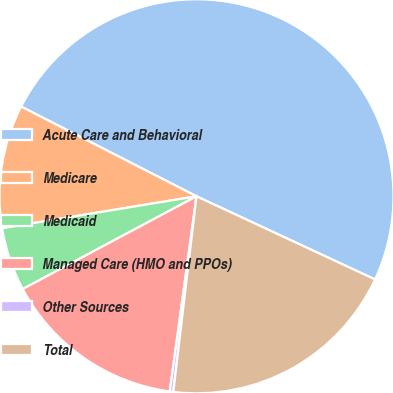Convert chart to OTSL. <chart><loc_0><loc_0><loc_500><loc_500><pie_chart><fcel>Acute Care and Behavioral<fcel>Medicare<fcel>Medicaid<fcel>Managed Care (HMO and PPOs)<fcel>Other Sources<fcel>Total<nl><fcel>49.41%<fcel>10.12%<fcel>5.21%<fcel>15.03%<fcel>0.29%<fcel>19.94%<nl></chart> 